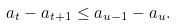Convert formula to latex. <formula><loc_0><loc_0><loc_500><loc_500>a _ { t } - a _ { t + 1 } \leq a _ { u - 1 } - a _ { u } .</formula> 